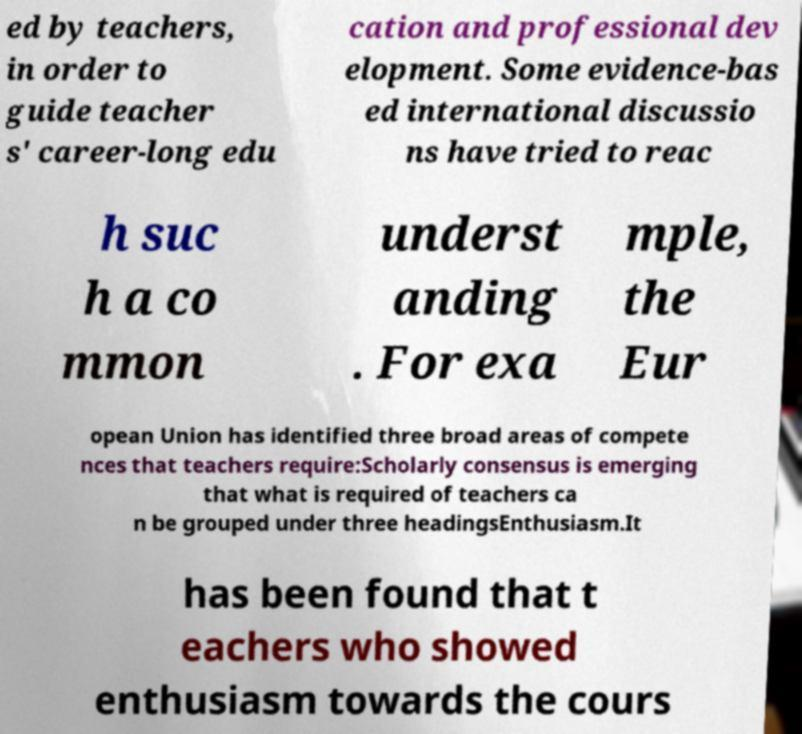What messages or text are displayed in this image? I need them in a readable, typed format. ed by teachers, in order to guide teacher s' career-long edu cation and professional dev elopment. Some evidence-bas ed international discussio ns have tried to reac h suc h a co mmon underst anding . For exa mple, the Eur opean Union has identified three broad areas of compete nces that teachers require:Scholarly consensus is emerging that what is required of teachers ca n be grouped under three headingsEnthusiasm.It has been found that t eachers who showed enthusiasm towards the cours 